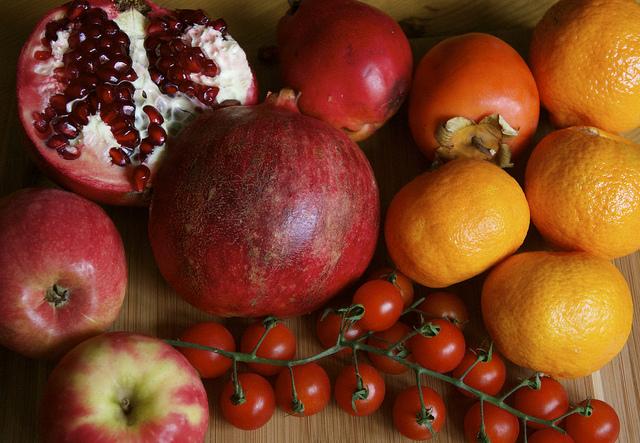What is this object?
Quick response, please. Fruit. How many fruits are here?
Keep it brief. 4. What is the red object on the left?
Short answer required. Apple. Are all the apples in baskets?
Quick response, please. No. Are there seeds visible?
Be succinct. Yes. What type of fruit has been cut in half?
Write a very short answer. Pomegranate. Has the fruit been sliced?
Concise answer only. Yes. What is still on a vine?
Give a very brief answer. Tomatoes. Are the oranges stacked on top of each other?
Keep it brief. No. 